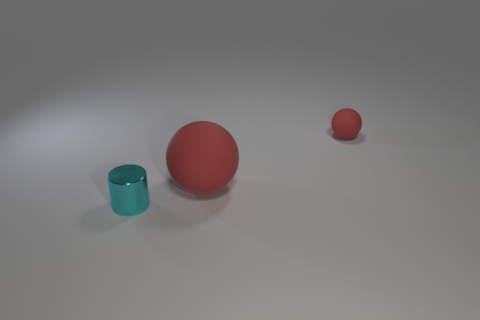What number of things are either tiny blue matte objects or objects left of the small red matte thing? In the image, there is one small blue matte cup and two objects on the left of the small red matte ball, making a total of three objects that meet the specified conditions. 